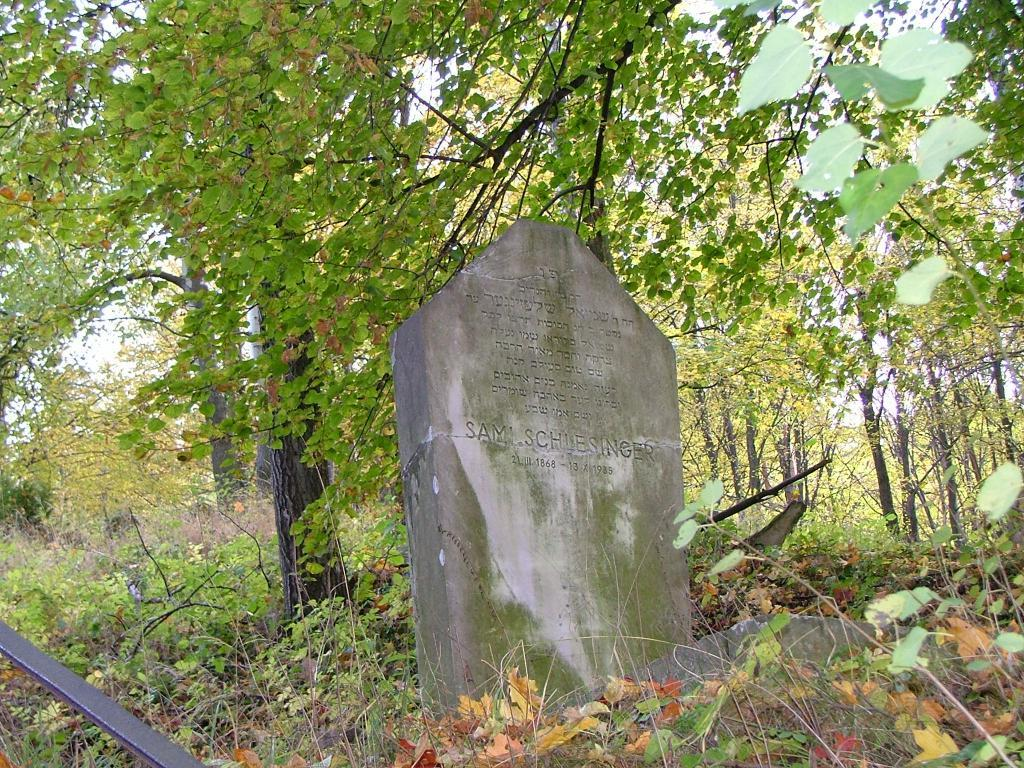What type of natural elements are present on the ground in the image? There are plants and trees on the ground in the image. What is visible at the top of the image? The sky is visible at the top of the image. What is the main structure in the center of the image? There is a tomb in the center of the image. What can be found on the tomb? There is text on the tomb. Can you hear the thunder in the image? There is no mention of thunder or any sound in the image, so it cannot be heard. Who is teaching in the image? There is no person teaching in the image. Where is the girl in the image? There is no girl present in the image. 